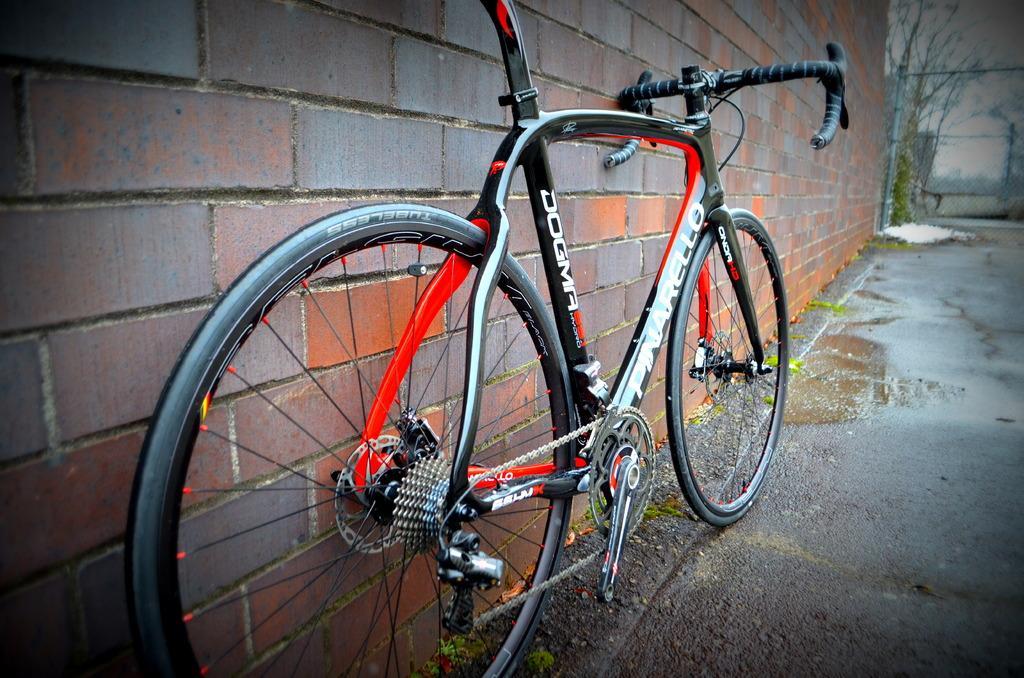Please provide a concise description of this image. In the picture I can see a bicycle on the ground. In the background I can see a brick wall, fence, trees and the sky. 